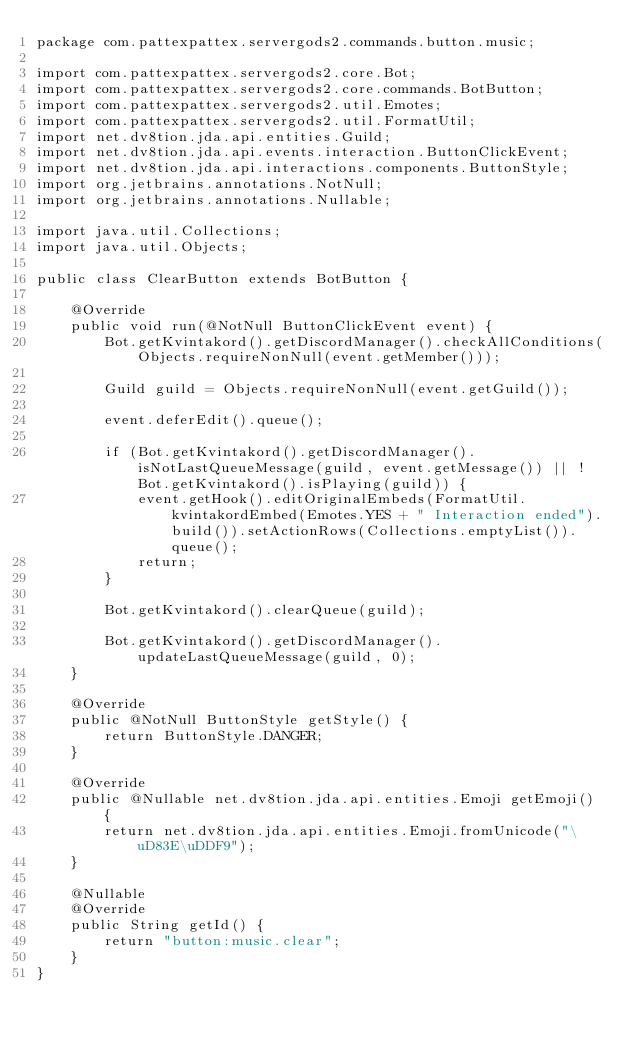<code> <loc_0><loc_0><loc_500><loc_500><_Java_>package com.pattexpattex.servergods2.commands.button.music;

import com.pattexpattex.servergods2.core.Bot;
import com.pattexpattex.servergods2.core.commands.BotButton;
import com.pattexpattex.servergods2.util.Emotes;
import com.pattexpattex.servergods2.util.FormatUtil;
import net.dv8tion.jda.api.entities.Guild;
import net.dv8tion.jda.api.events.interaction.ButtonClickEvent;
import net.dv8tion.jda.api.interactions.components.ButtonStyle;
import org.jetbrains.annotations.NotNull;
import org.jetbrains.annotations.Nullable;

import java.util.Collections;
import java.util.Objects;

public class ClearButton extends BotButton {

    @Override
    public void run(@NotNull ButtonClickEvent event) {
        Bot.getKvintakord().getDiscordManager().checkAllConditions(Objects.requireNonNull(event.getMember()));

        Guild guild = Objects.requireNonNull(event.getGuild());

        event.deferEdit().queue();

        if (Bot.getKvintakord().getDiscordManager().isNotLastQueueMessage(guild, event.getMessage()) || !Bot.getKvintakord().isPlaying(guild)) {
            event.getHook().editOriginalEmbeds(FormatUtil.kvintakordEmbed(Emotes.YES + " Interaction ended").build()).setActionRows(Collections.emptyList()).queue();
            return;
        }

        Bot.getKvintakord().clearQueue(guild);

        Bot.getKvintakord().getDiscordManager().updateLastQueueMessage(guild, 0);
    }

    @Override
    public @NotNull ButtonStyle getStyle() {
        return ButtonStyle.DANGER;
    }

    @Override
    public @Nullable net.dv8tion.jda.api.entities.Emoji getEmoji() {
        return net.dv8tion.jda.api.entities.Emoji.fromUnicode("\uD83E\uDDF9");
    }

    @Nullable
    @Override
    public String getId() {
        return "button:music.clear";
    }
}
</code> 